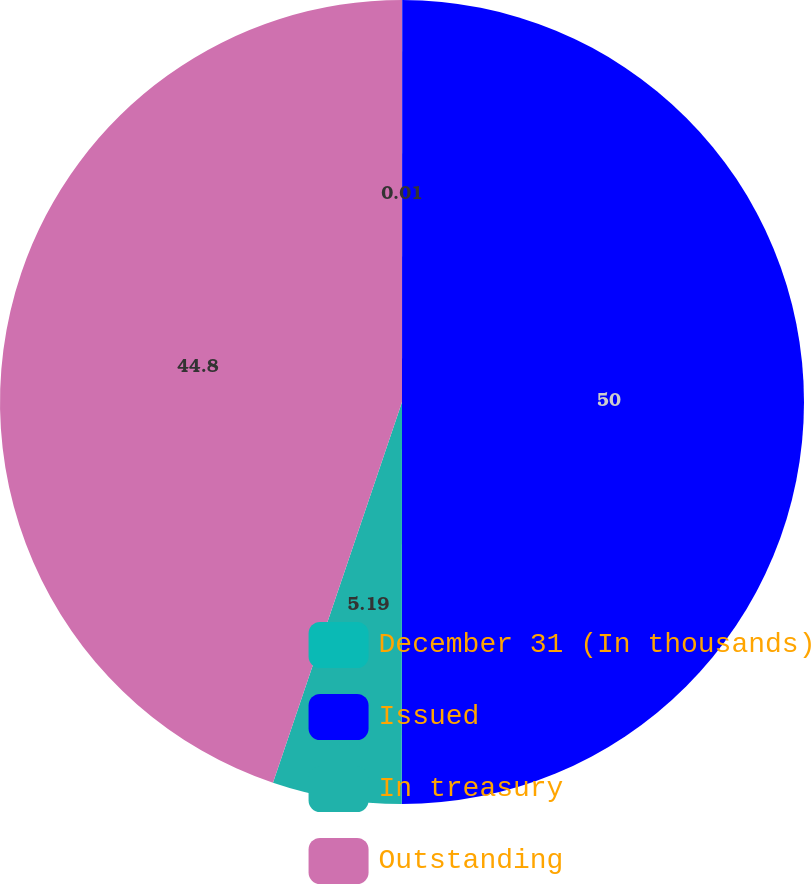Convert chart to OTSL. <chart><loc_0><loc_0><loc_500><loc_500><pie_chart><fcel>December 31 (In thousands)<fcel>Issued<fcel>In treasury<fcel>Outstanding<nl><fcel>0.01%<fcel>50.0%<fcel>5.19%<fcel>44.8%<nl></chart> 